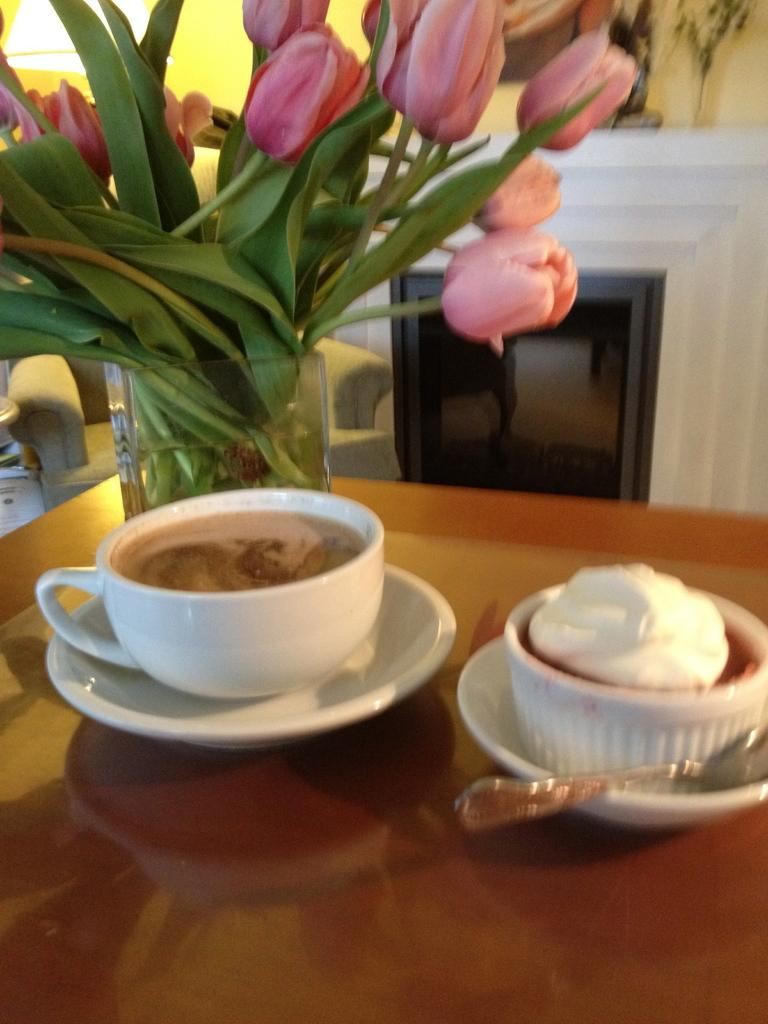What is in the cup that is visible in the image? There is a drink in the cup in the image. What accompanies the cup in the image? There is a saucer in the image. What food item can be seen with a spoon in the image? There is a food item with a spoon in the image. What decorative item is present on the table in the image? There is a flower vase on the table in the image. What is inside the flower vase? The flower vase contains flowers. What type of tramp is visible in the image? There is no tramp present in the image. What things are being used to extract oil from the ground in the image? There is no mention of oil or oil extraction in the image. 